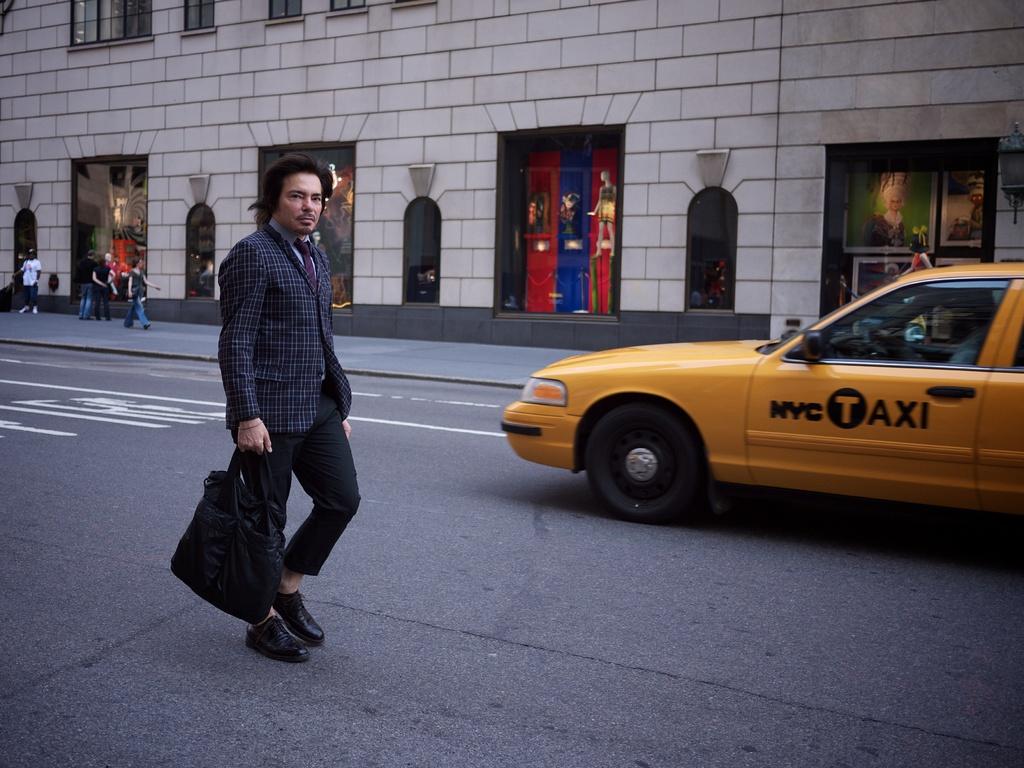What kind of taxi is it?
Offer a terse response. Nyc. What type of vehicle is this?
Your response must be concise. Taxi. 